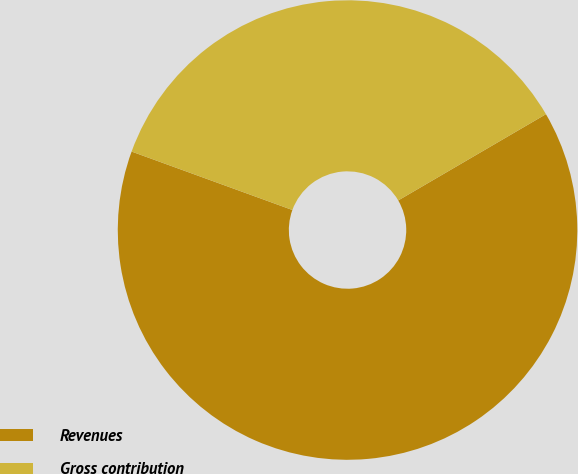Convert chart. <chart><loc_0><loc_0><loc_500><loc_500><pie_chart><fcel>Revenues<fcel>Gross contribution<nl><fcel>63.96%<fcel>36.04%<nl></chart> 